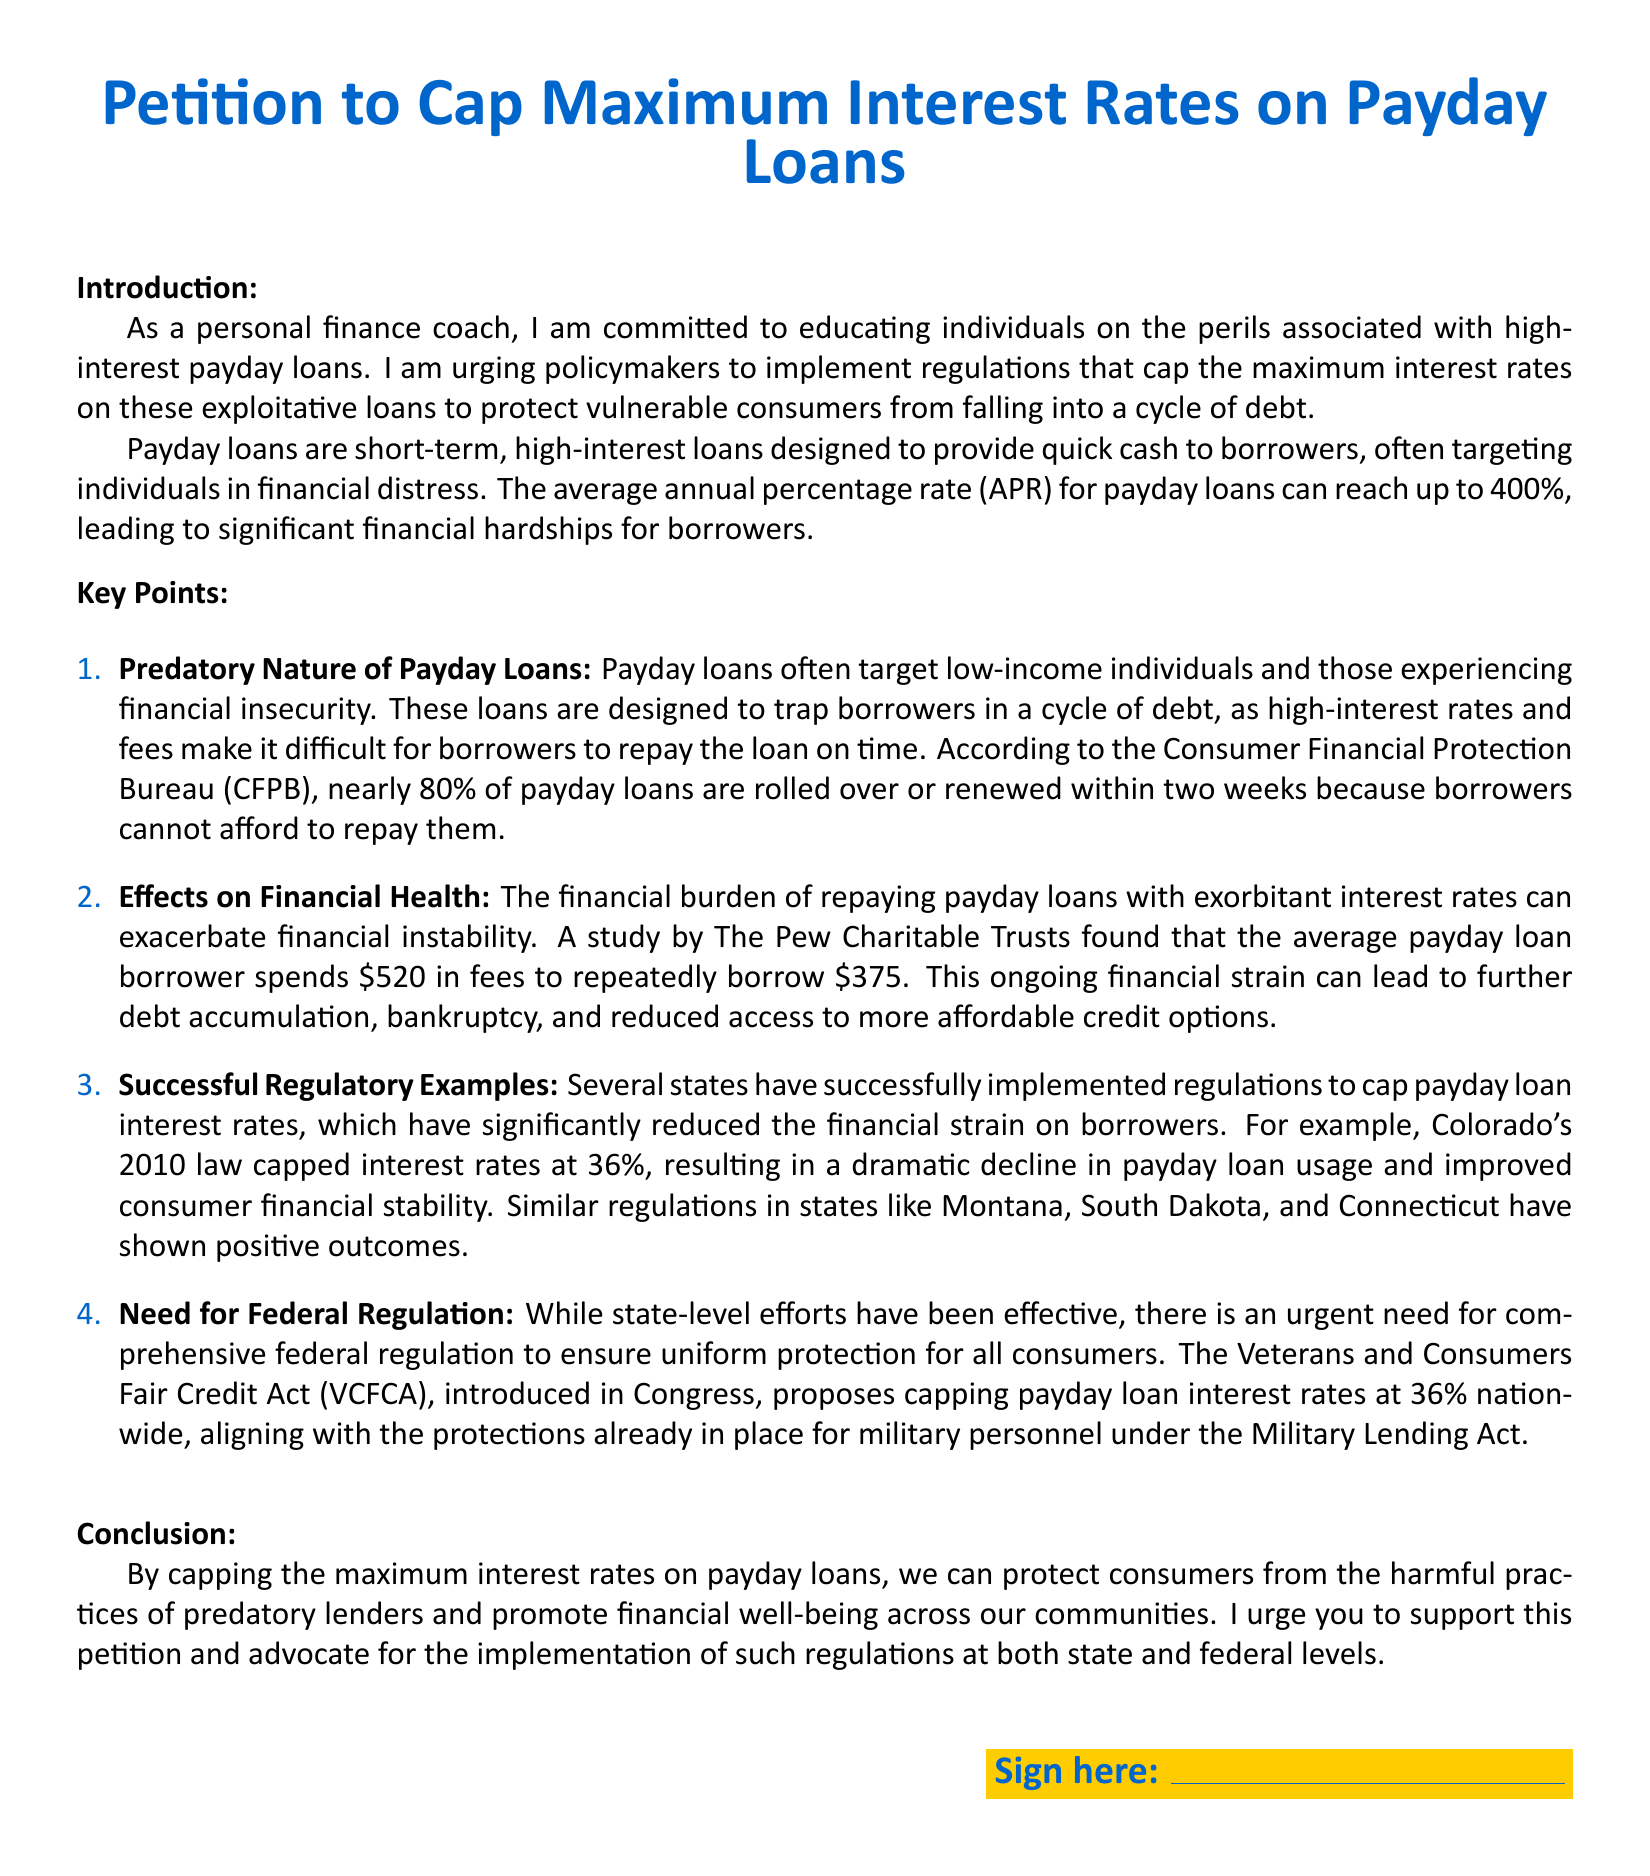what is the maximum annual percentage rate for payday loans? The document states that the average annual percentage rate (APR) for payday loans can reach up to 400%.
Answer: 400% what is the percentage of payday loans that are rolled over or renewed within two weeks? According to the Consumer Financial Protection Bureau (CFPB), nearly 80% of payday loans are rolled over or renewed within two weeks.
Answer: 80% which state’s law caps interest rates at 36%? The document mentions that Colorado's 2010 law capped interest rates at 36%.
Answer: Colorado what was the average amount spent in fees by a payday loan borrower to borrow $375? A study by The Pew Charitable Trusts found that the average payday loan borrower spends $520 in fees to repeatedly borrow $375.
Answer: $520 what act is proposing a cap on payday loan interest rates at 36% nationwide? The Veterans and Consumers Fair Credit Act (VCFCA) proposes capping payday loan interest rates at 36% nationwide.
Answer: VCFCA what is the primary purpose of capping maximum interest rates on payday loans according to the petition? The primary purpose is to protect consumers from the harmful practices of predatory lenders.
Answer: Protect consumers how many key points are outlined in the document? The document lists four key points regarding payday loans.
Answer: Four which color is used in the title of the petition? The title of the petition is in main color, which is defined as RGB(0,102,204).
Answer: main color what financial outcome did regulations in states like Montana, South Dakota, and Connecticut show? The document indicates that regulations in these states have shown positive outcomes.
Answer: Positive outcomes 